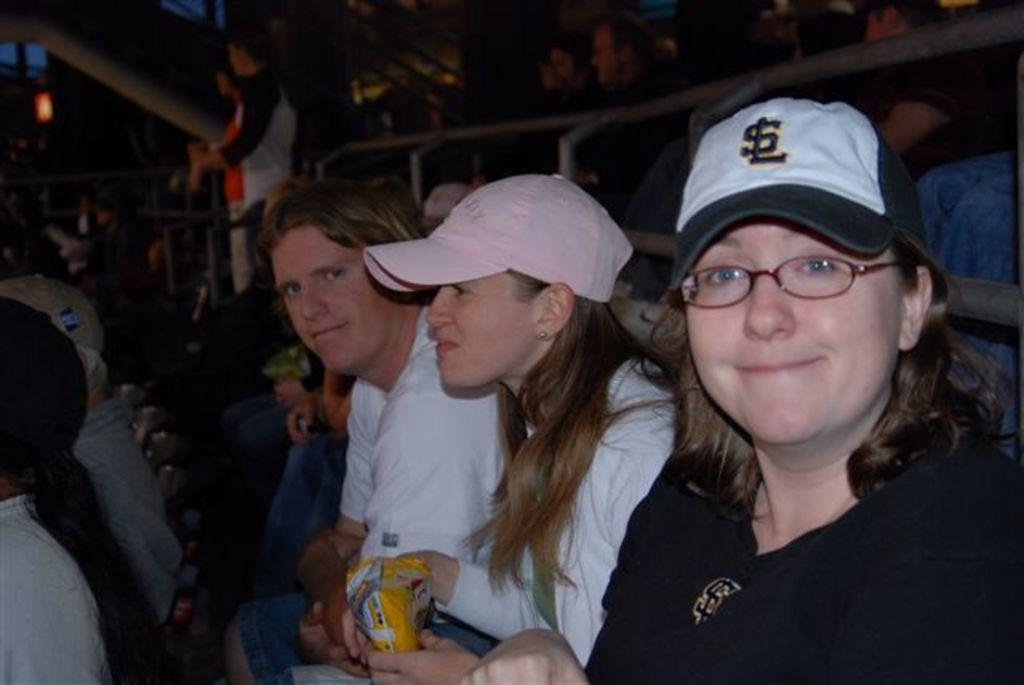How would you summarize this image in a sentence or two? In this image, I can see groups of people sitting on the chairs. I think this is a kind of barricade. Here is a person standing. In the background, that looks like a light. 